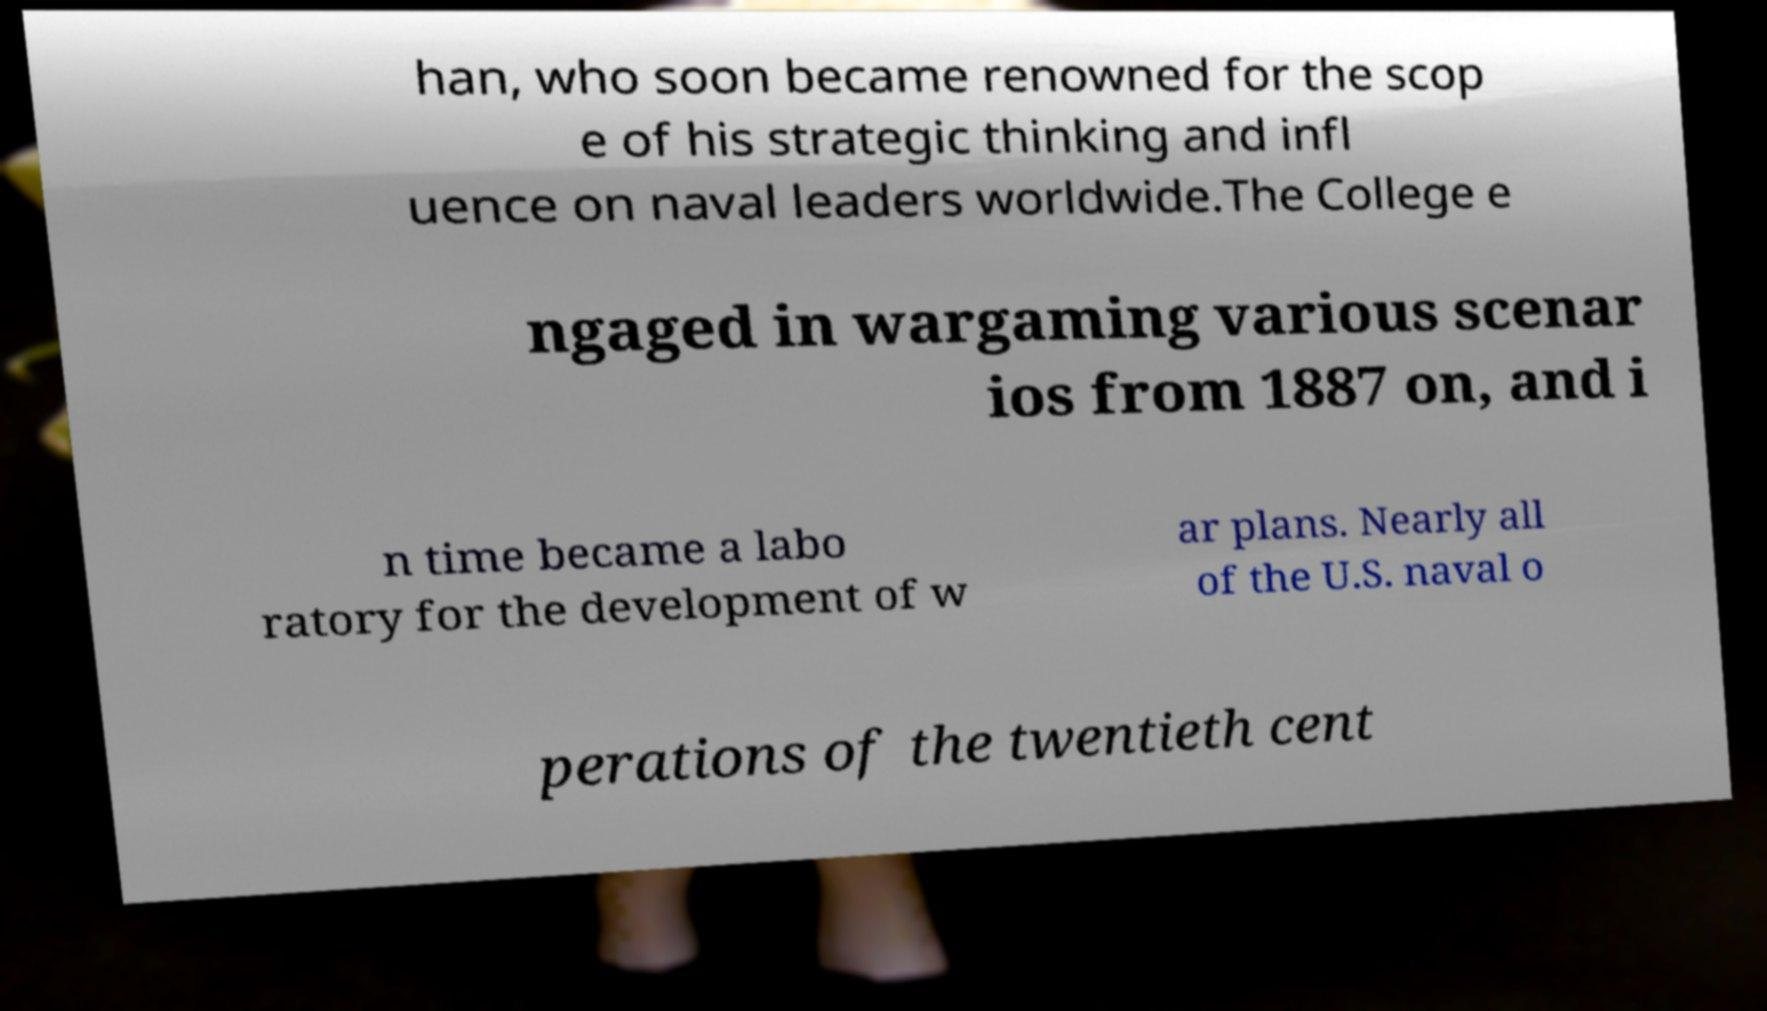For documentation purposes, I need the text within this image transcribed. Could you provide that? han, who soon became renowned for the scop e of his strategic thinking and infl uence on naval leaders worldwide.The College e ngaged in wargaming various scenar ios from 1887 on, and i n time became a labo ratory for the development of w ar plans. Nearly all of the U.S. naval o perations of the twentieth cent 